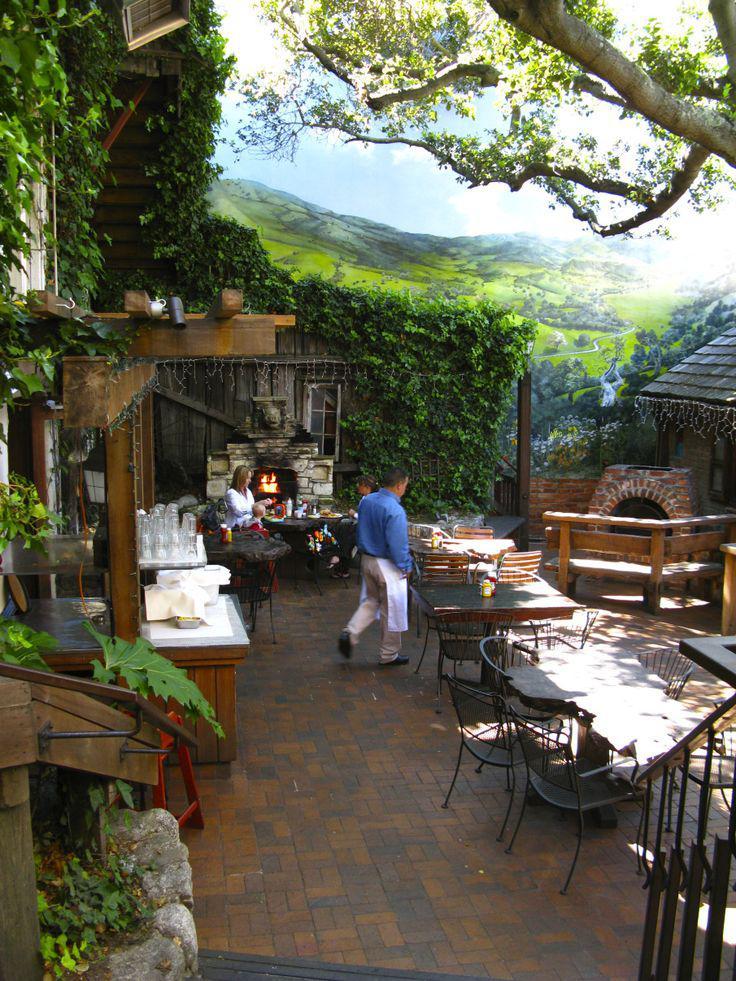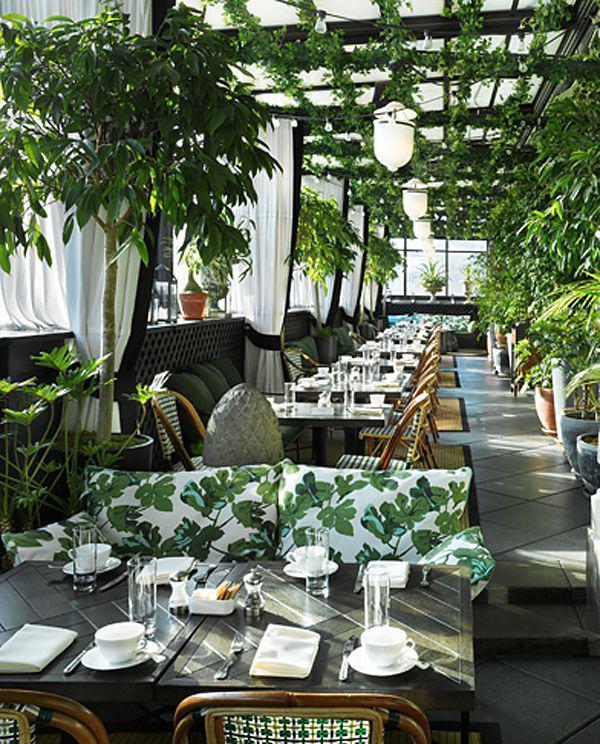The first image is the image on the left, the second image is the image on the right. Assess this claim about the two images: "At least one restaurant's tables are sitting outdoors in the open air.". Correct or not? Answer yes or no. Yes. The first image is the image on the left, the second image is the image on the right. Given the left and right images, does the statement "The left and right image each contain at least five square light brown wooden dining tables." hold true? Answer yes or no. No. 